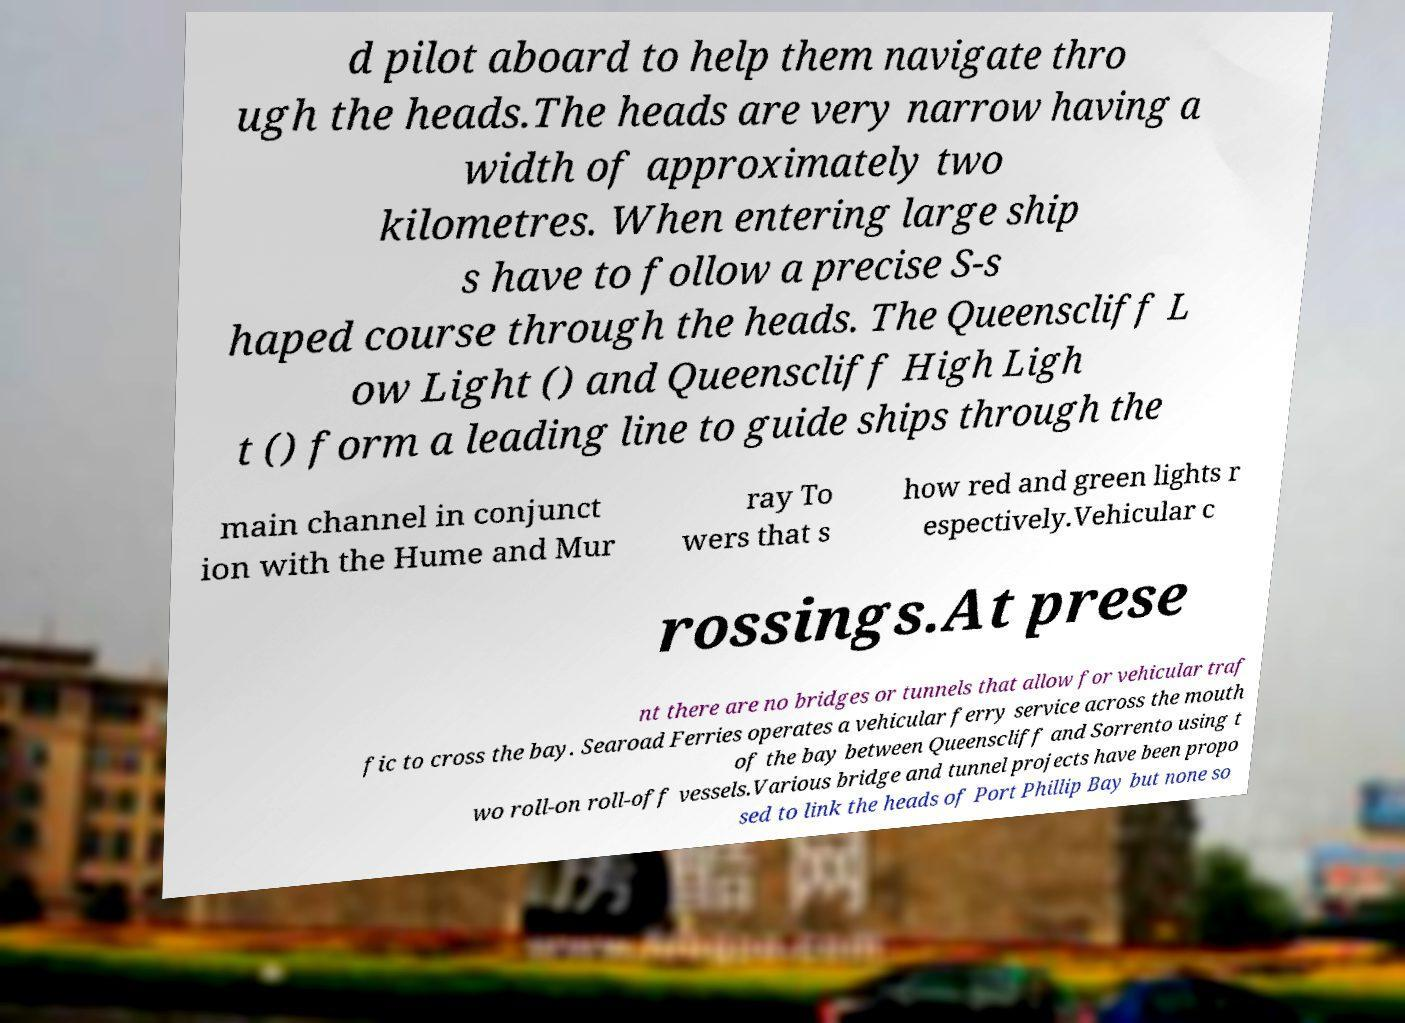I need the written content from this picture converted into text. Can you do that? d pilot aboard to help them navigate thro ugh the heads.The heads are very narrow having a width of approximately two kilometres. When entering large ship s have to follow a precise S-s haped course through the heads. The Queenscliff L ow Light () and Queenscliff High Ligh t () form a leading line to guide ships through the main channel in conjunct ion with the Hume and Mur ray To wers that s how red and green lights r espectively.Vehicular c rossings.At prese nt there are no bridges or tunnels that allow for vehicular traf fic to cross the bay. Searoad Ferries operates a vehicular ferry service across the mouth of the bay between Queenscliff and Sorrento using t wo roll-on roll-off vessels.Various bridge and tunnel projects have been propo sed to link the heads of Port Phillip Bay but none so 